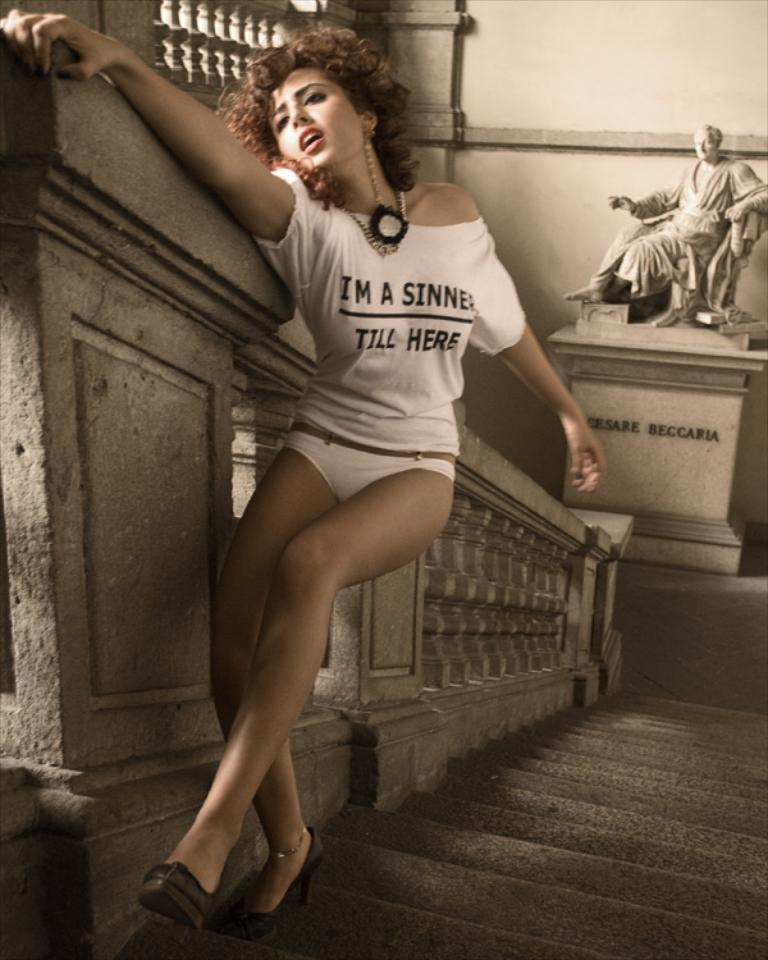What is the main subject of the image? There is a lady standing in the center of the image. What is the lady holding in the image? The lady is holding a wall. What architectural feature can be seen in the image? There are stairs visible in the image. What can be seen in the background of the image? There is a statue in the background of the image. What type of brick is the lady using to test her strength in the image? There is no brick present in the image, and the lady is not testing her strength. 